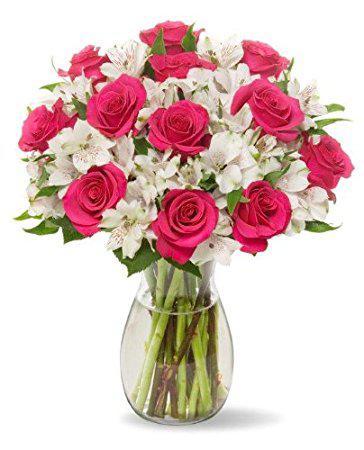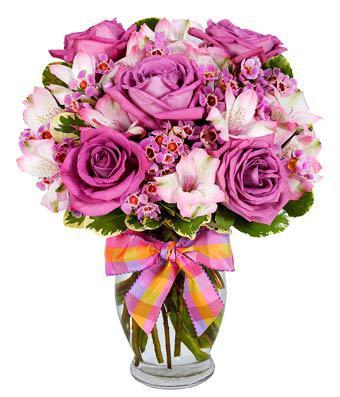The first image is the image on the left, the second image is the image on the right. Evaluate the accuracy of this statement regarding the images: "No vase includes only roses, and at least one vase is decorated with a ribbon tied in a bow.". Is it true? Answer yes or no. Yes. The first image is the image on the left, the second image is the image on the right. Evaluate the accuracy of this statement regarding the images: "There is a bow around the vase in the image on the right.". Is it true? Answer yes or no. Yes. 